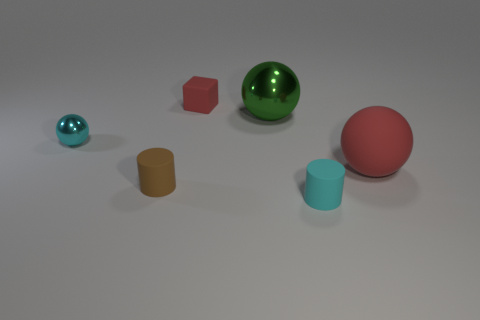How does the lighting in this image affect the perception of the objects? The lighting in this image is soft and diffused, creating subtle shadows and highlights that enhance the dimensional quality of the objects. It allows the viewer to perceive the curvature of the spheres and the flat surfaces of the cube and cylinders. This kind of lighting ensures that colors and shapes are distinct without any harsh or distracting shadows. 